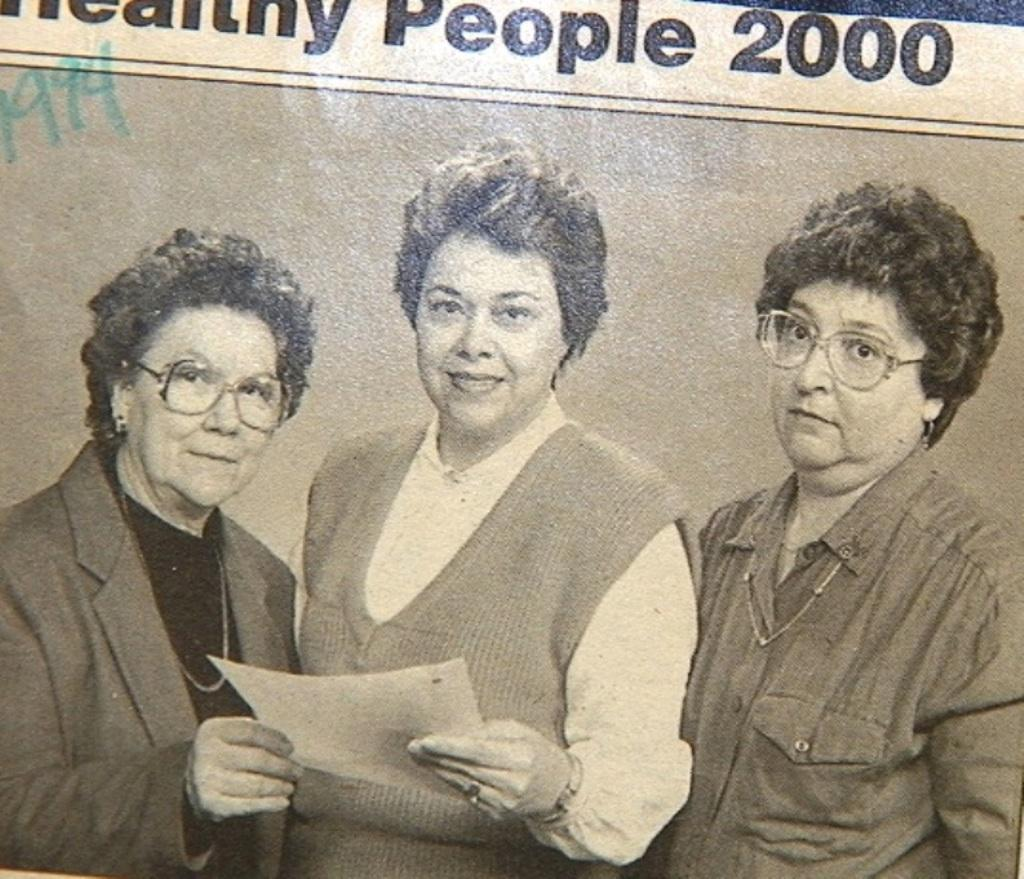What is present in the image that contains an image of three persons standing? There is a paper in the image that contains an image of three persons standing. Who is holding the paper in the image? There is a person holding a paper in the image. What can be found on the paper besides the image of three persons standing? The paper has words and numbers on it. What type of copper can be seen in the image? There is no copper present in the image. What kind of quartz is visible on the paper? There is no quartz present in the image. 